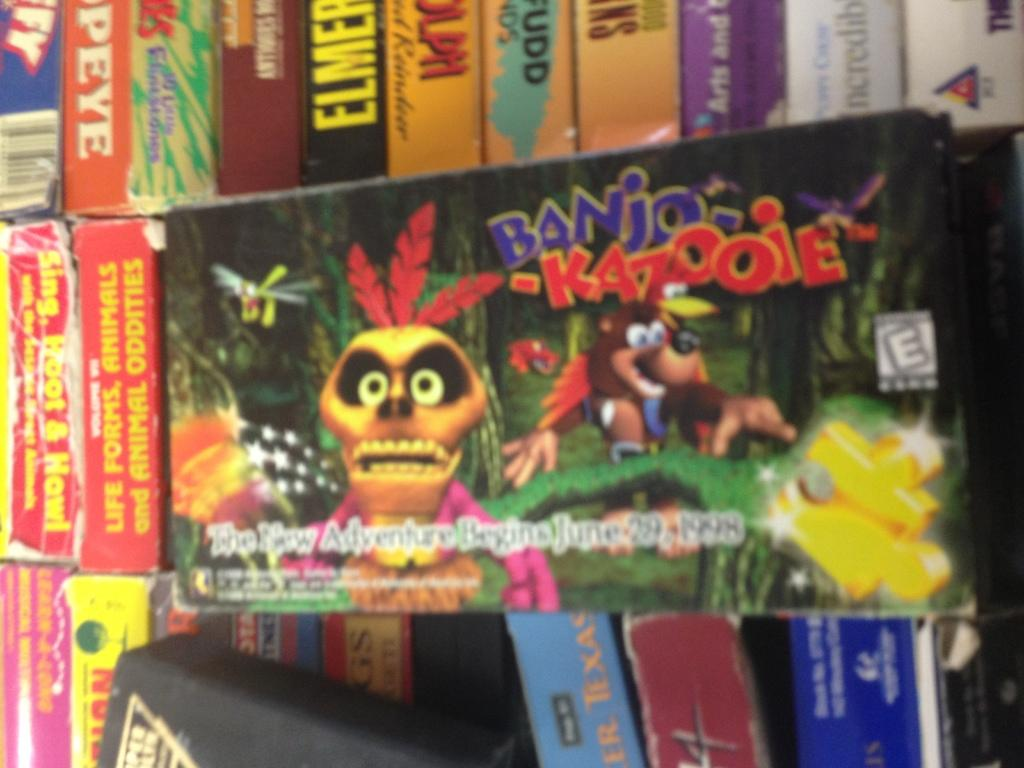<image>
Create a compact narrative representing the image presented. Banjo-Kazooie is rated E for everyone, so we can play it anytime. 